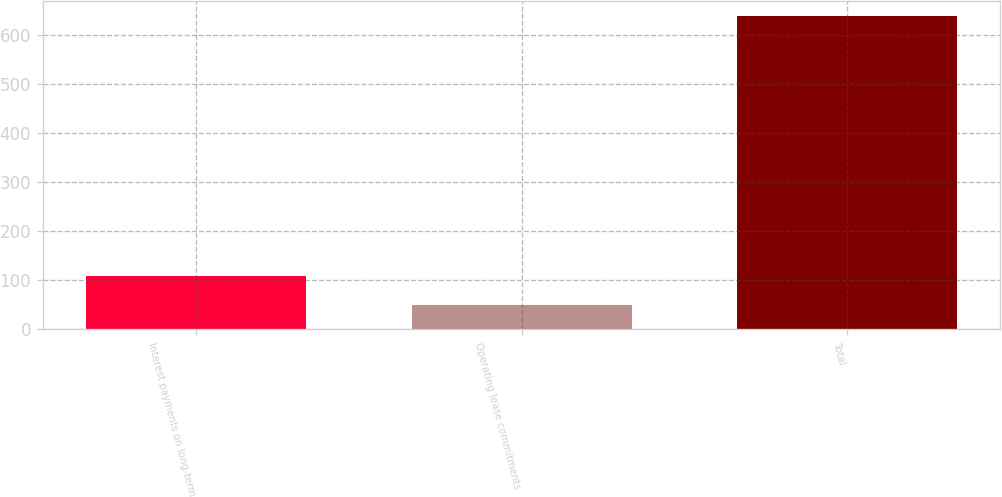Convert chart to OTSL. <chart><loc_0><loc_0><loc_500><loc_500><bar_chart><fcel>Interest payments on long-term<fcel>Operating lease commitments<fcel>Total<nl><fcel>108.9<fcel>50<fcel>639<nl></chart> 